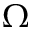<formula> <loc_0><loc_0><loc_500><loc_500>\Omega</formula> 